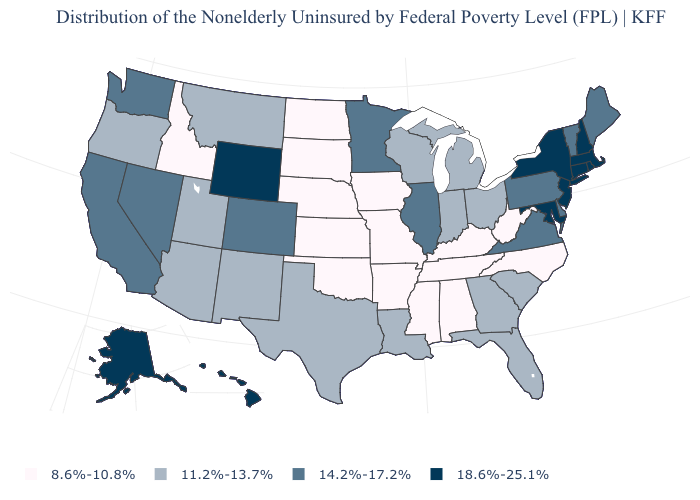What is the value of Alaska?
Answer briefly. 18.6%-25.1%. Which states have the lowest value in the USA?
Write a very short answer. Alabama, Arkansas, Idaho, Iowa, Kansas, Kentucky, Mississippi, Missouri, Nebraska, North Carolina, North Dakota, Oklahoma, South Dakota, Tennessee, West Virginia. Name the states that have a value in the range 18.6%-25.1%?
Give a very brief answer. Alaska, Connecticut, Hawaii, Maryland, Massachusetts, New Hampshire, New Jersey, New York, Rhode Island, Wyoming. Is the legend a continuous bar?
Answer briefly. No. What is the value of Illinois?
Quick response, please. 14.2%-17.2%. What is the value of New Hampshire?
Concise answer only. 18.6%-25.1%. Which states have the highest value in the USA?
Concise answer only. Alaska, Connecticut, Hawaii, Maryland, Massachusetts, New Hampshire, New Jersey, New York, Rhode Island, Wyoming. Which states have the lowest value in the Northeast?
Write a very short answer. Maine, Pennsylvania, Vermont. What is the value of Georgia?
Answer briefly. 11.2%-13.7%. What is the value of New Hampshire?
Quick response, please. 18.6%-25.1%. Does South Dakota have the same value as Kansas?
Concise answer only. Yes. Which states have the lowest value in the South?
Answer briefly. Alabama, Arkansas, Kentucky, Mississippi, North Carolina, Oklahoma, Tennessee, West Virginia. What is the value of Montana?
Answer briefly. 11.2%-13.7%. Among the states that border Kansas , does Colorado have the lowest value?
Be succinct. No. Does South Dakota have the lowest value in the USA?
Quick response, please. Yes. 